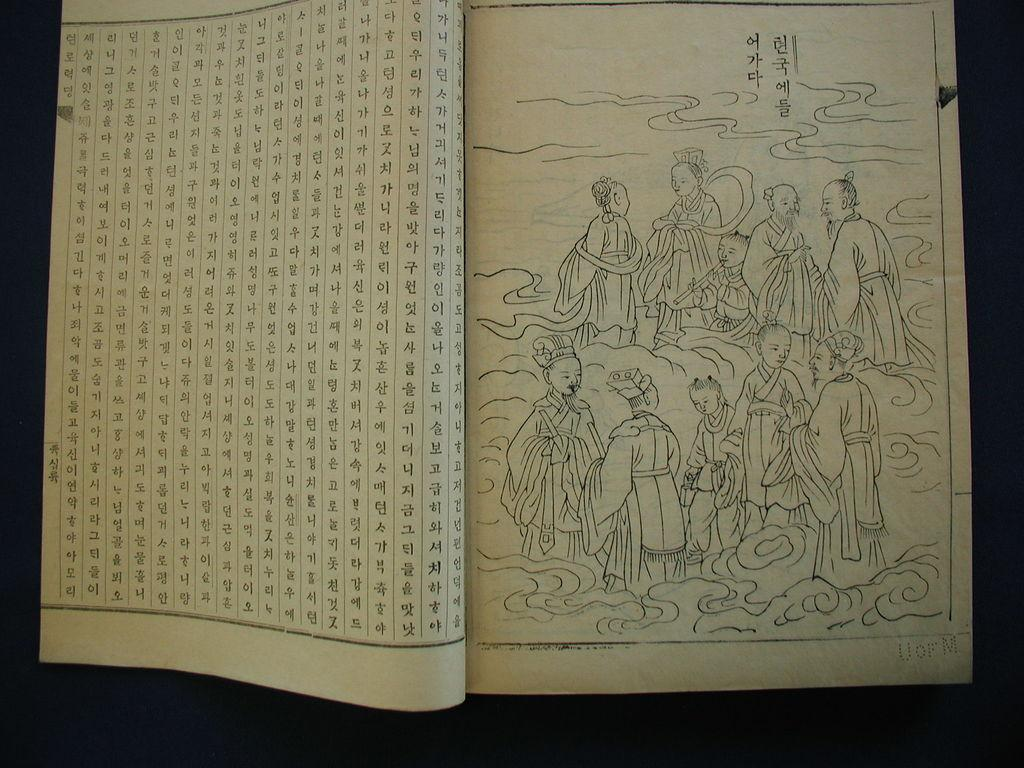What object is placed on the table in the image? There is a book placed on a table. What type of day is depicted in the image? The image does not depict a day; it features a book placed on a table. What type of wing is visible on the book in the image? There are no wings present on the book in the image. 